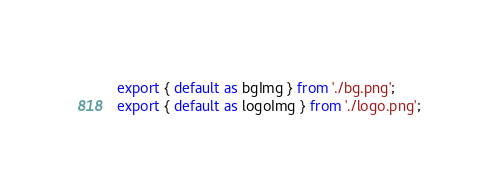Convert code to text. <code><loc_0><loc_0><loc_500><loc_500><_TypeScript_>export { default as bgImg } from './bg.png';
export { default as logoImg } from './logo.png';
</code> 